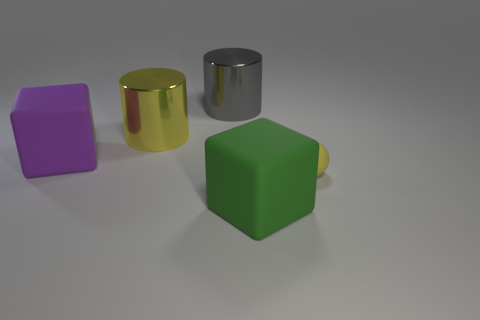Are the object in front of the tiny yellow thing and the purple thing made of the same material?
Ensure brevity in your answer.  Yes. Is the number of matte blocks that are in front of the large purple cube the same as the number of large green blocks?
Your answer should be compact. Yes. What size is the sphere?
Give a very brief answer. Small. What is the material of the object that is the same color as the ball?
Your answer should be very brief. Metal. How many big cylinders are the same color as the small sphere?
Offer a terse response. 1. Do the gray shiny object and the matte sphere have the same size?
Keep it short and to the point. No. There is a matte thing that is to the right of the cube that is to the right of the gray object; what is its size?
Offer a very short reply. Small. There is a ball; does it have the same color as the big cylinder in front of the gray metal object?
Provide a succinct answer. Yes. Is there a purple rubber thing that has the same size as the yellow metal thing?
Your answer should be compact. Yes. There is a yellow thing on the right side of the big gray object; what is its size?
Provide a succinct answer. Small. 